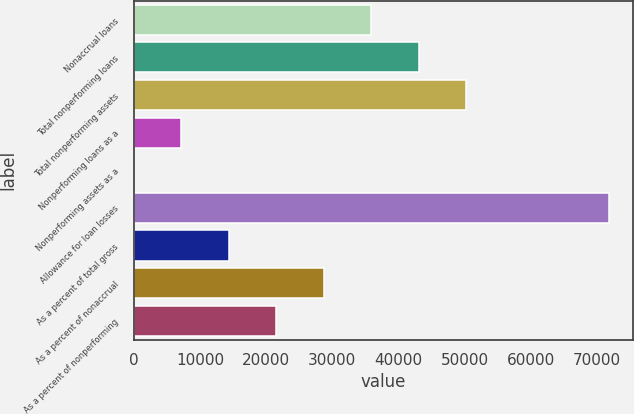<chart> <loc_0><loc_0><loc_500><loc_500><bar_chart><fcel>Nonaccrual loans<fcel>Total nonperforming loans<fcel>Total nonperforming assets<fcel>Nonperforming loans as a<fcel>Nonperforming assets as a<fcel>Allowance for loan losses<fcel>As a percent of total gross<fcel>As a percent of nonaccrual<fcel>As a percent of nonperforming<nl><fcel>35900.3<fcel>43080.2<fcel>50260.2<fcel>7180.54<fcel>0.6<fcel>71800<fcel>14360.5<fcel>28720.4<fcel>21540.4<nl></chart> 